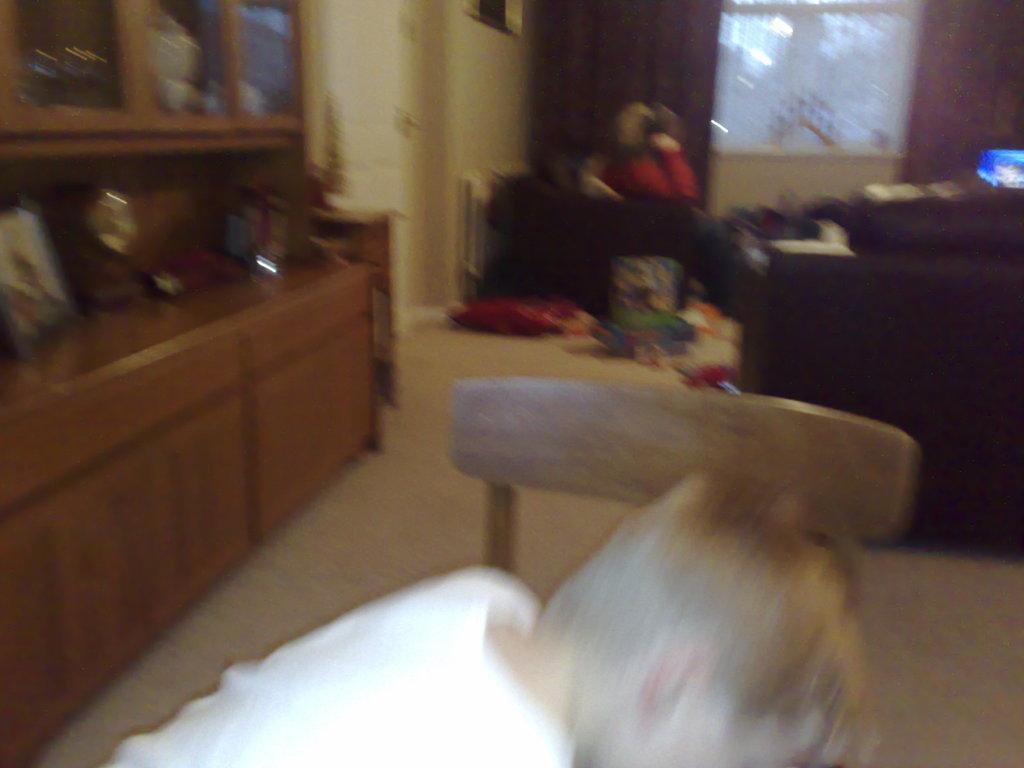Could you give a brief overview of what you see in this image? In the image we can see a child wearing clothes and sitting on the chair. This is a chair, floor, cupboards, window and curtains. We can even see there is a sofa and the image is blurred. 